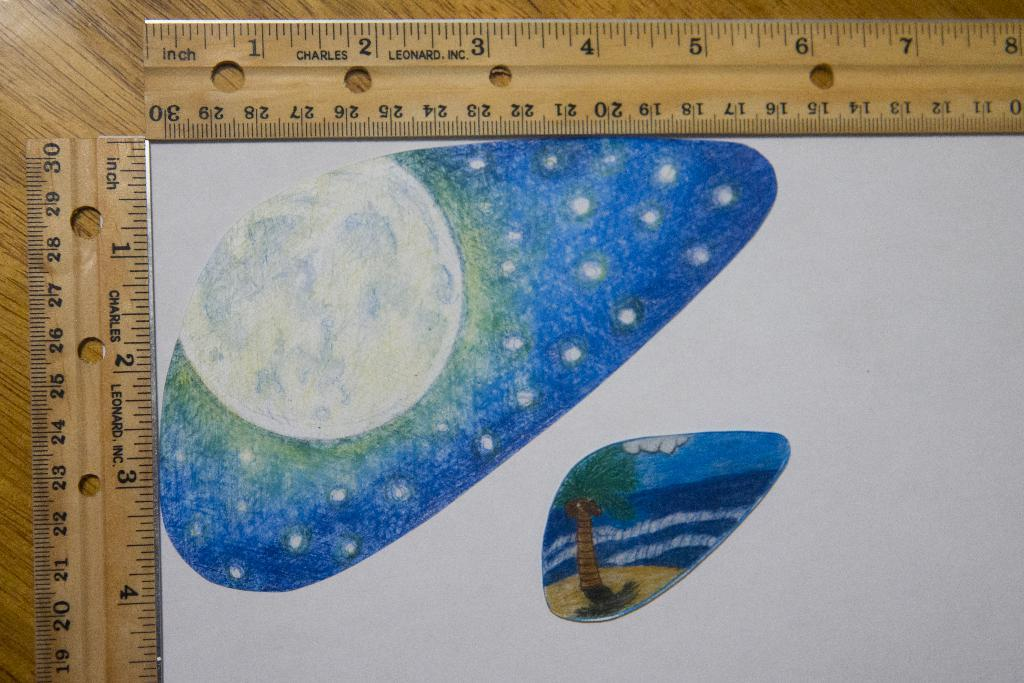What type of furniture is present in the image? There is a table in the image. What objects are placed on the table? There are two scales and a paper on the table. What is depicted on the paper? There is an art piece on the paper. How many candles are on the cake in the image? There is no cake present in the image. What type of show is being performed on the table in the image? There is no show being performed in the image; it features a table with two scales, a paper, and an art piece. 